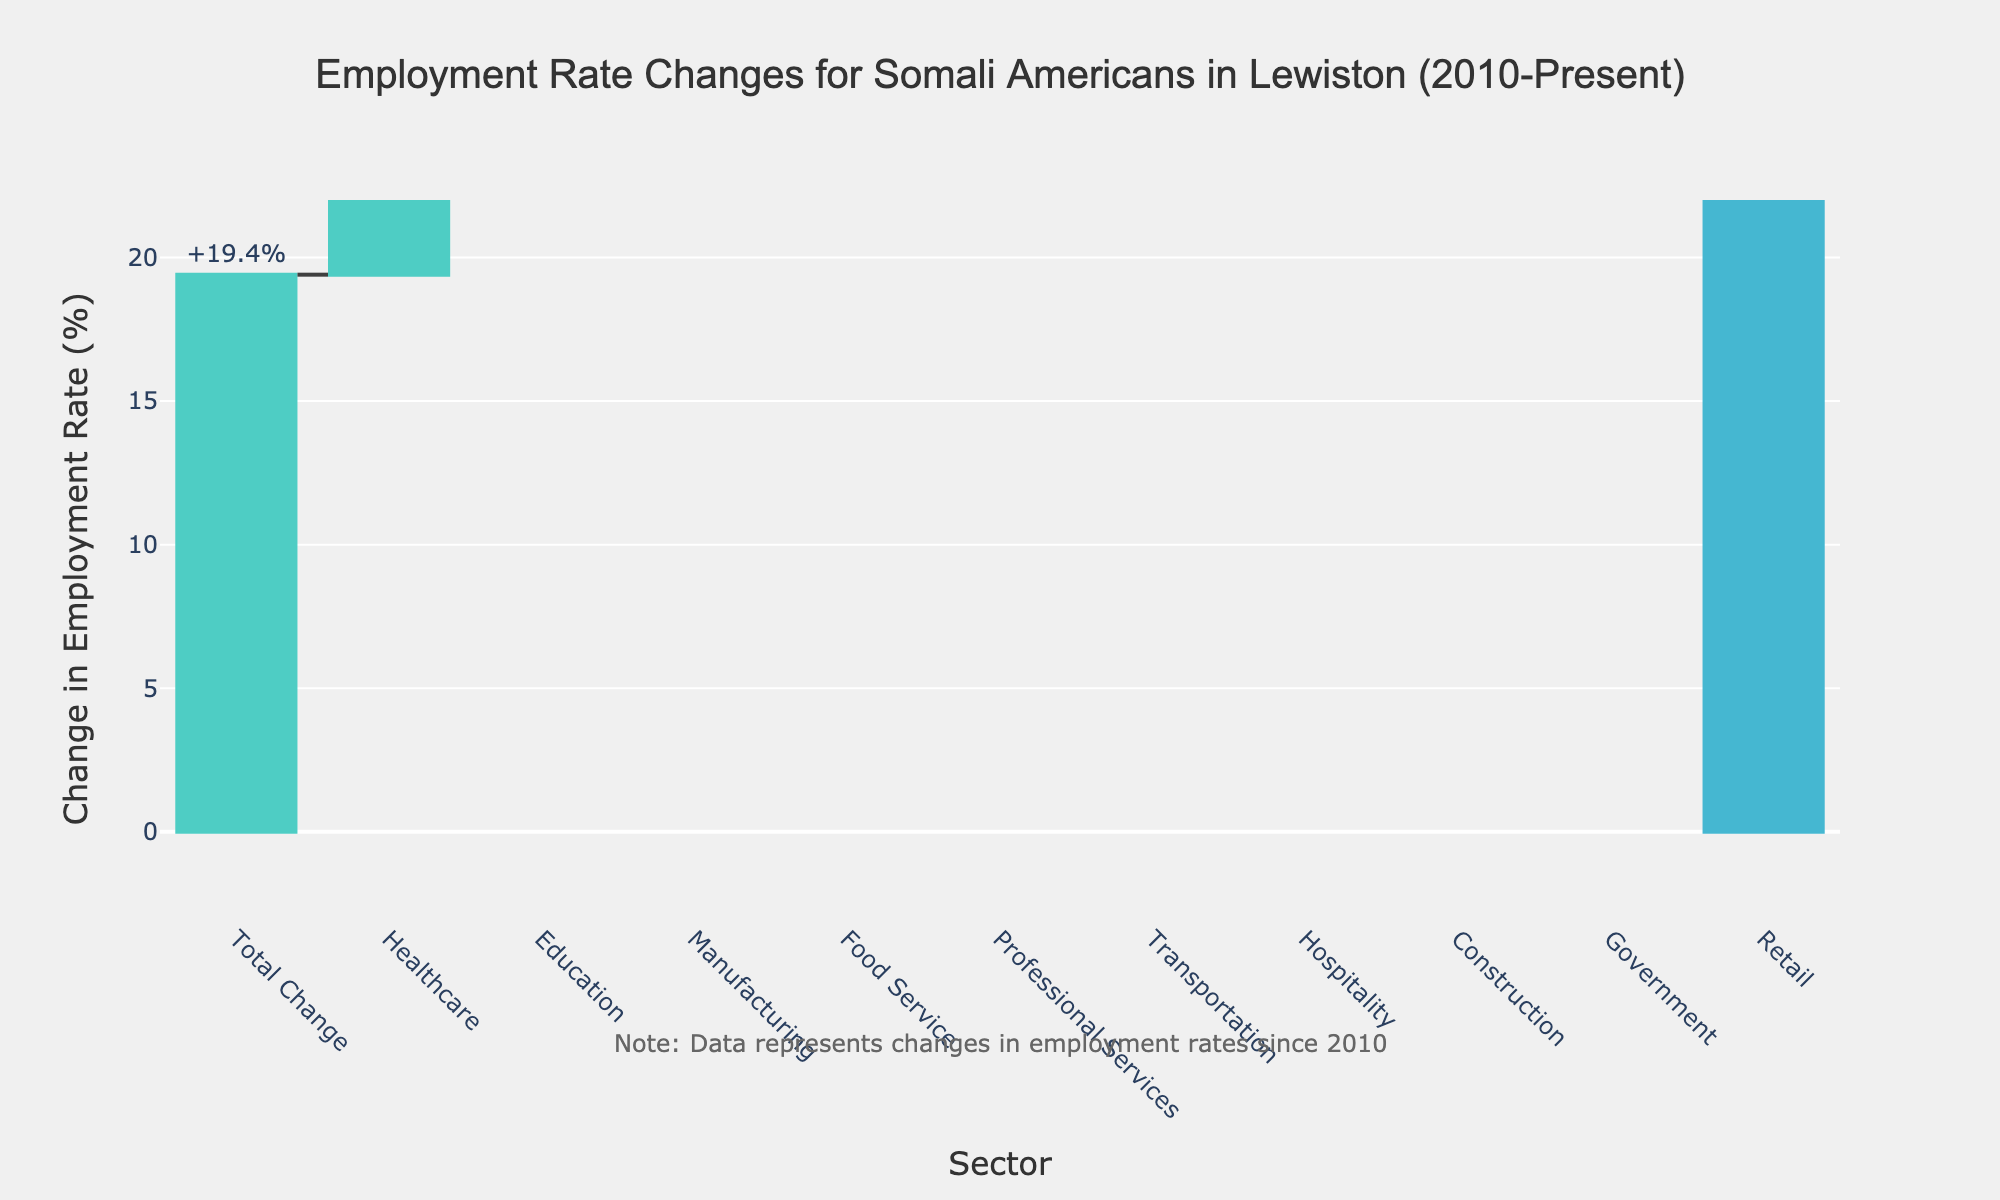What is the sector with the largest increase in employment rate? The sector with the largest increase in employment rate can be identified by looking at the tallest green bar in the waterfall chart.
Answer: Healthcare What is the total change in employment rate since 2010? The total change in employment rate is represented by the "Total Change" category, which shows the overall increase or decrease for all sectors combined.
Answer: +19.4% Which sector experienced a decrease in employment rate? To find the sectors with a decrease, look for the red bars. There are bars for Retail and Government that represent a decrease in employment rate.
Answer: Retail, Government How much has the employment rate changed in the Food Service sector? The change in the Food Service sector can be seen from the height of its bar in the chart and its label.
Answer: +2.9% How many sectors have an increase in employment rate? Count the number of green bars in the chart to determine how many sectors saw an increase in employment rate.
Answer: 8 What is the difference in employment rate change between Education and Manufacturing? The difference is found by subtracting the change in Manufacturing from the change in Education. Education is +4.1%, and Manufacturing is +3.2%. So, 4.1 - 3.2 = 0.9.
Answer: +0.9% Which sector has seen a greater increase in employment rate: Professional Services or Hospitality? Compare the heights and labels of the bars for Professional Services and Hospitality. Professional Services is +2.3% and Hospitality is +1.2%.
Answer: Professional Services What is the average change in employment rate across all sectors? Sum all the individual sector changes and divide by the number of sectors (excluding the total). Sum = 3.2 + 5.7 + (-1.8) + 4.1 + 2.9 + 1.5 + 0.8 + (-0.5) + 1.2 + 2.3 = 19.4. Number of sectors = 10, excluding total. Average = 19.4 / 10 = 1.94.
Answer: +1.94% What is the employment rate change for the Transportation sector, and how does it compare to that of Construction? The employment rate change in the Transportation sector is +1.5% and for Construction, it is +0.8%. Compare by noting which value is higher.
Answer: Transportation is higher than Construction 